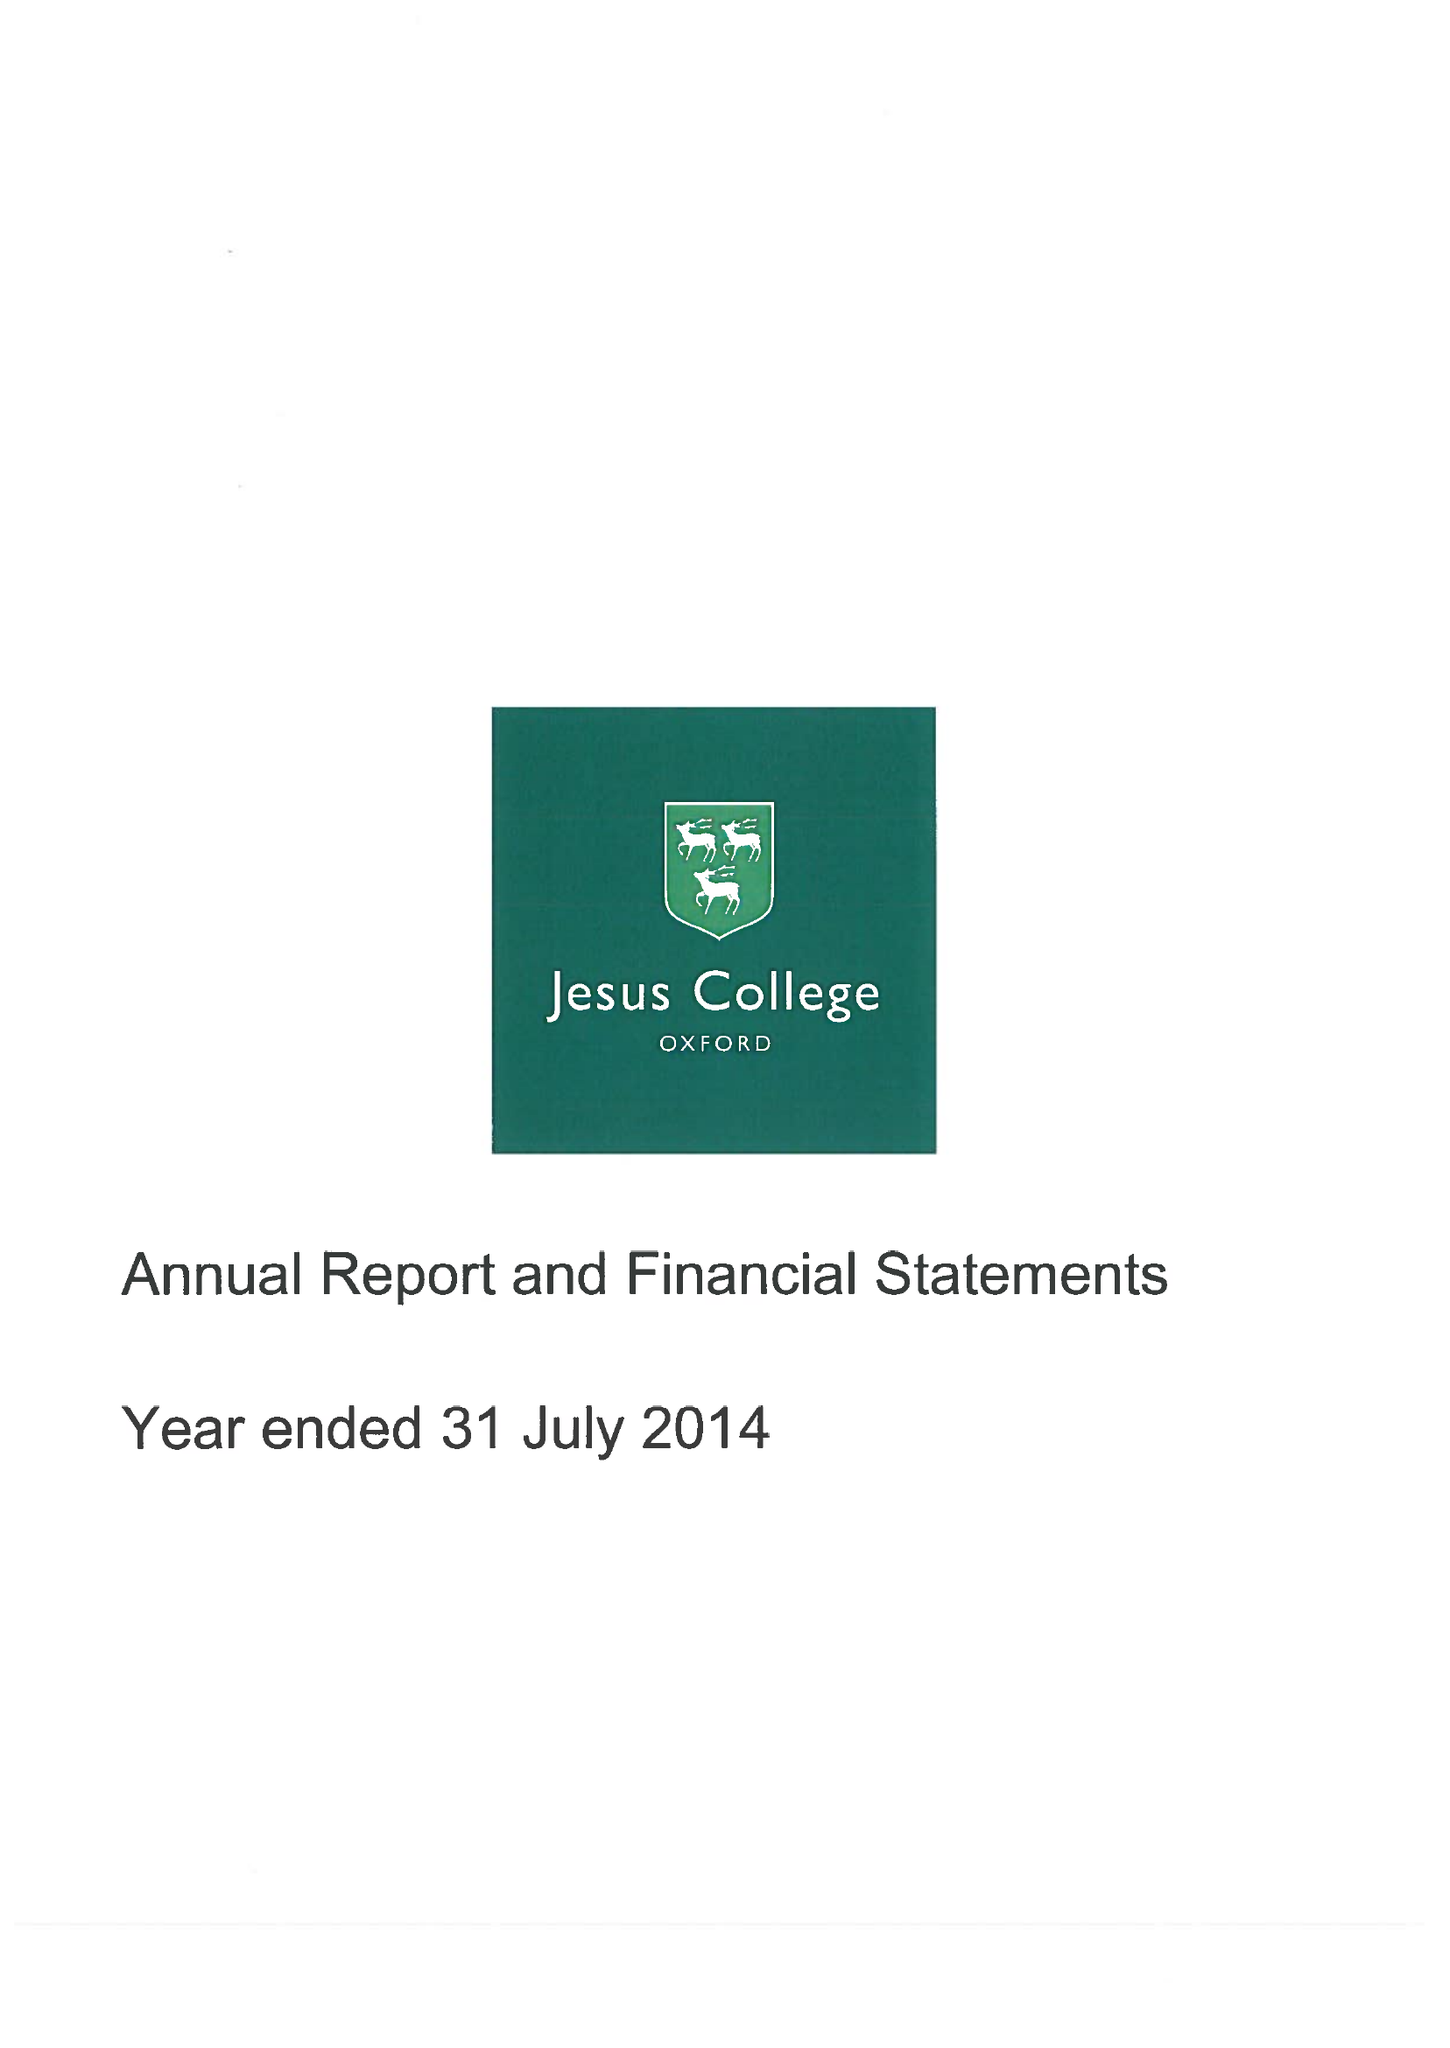What is the value for the income_annually_in_british_pounds?
Answer the question using a single word or phrase. 12139000.00 